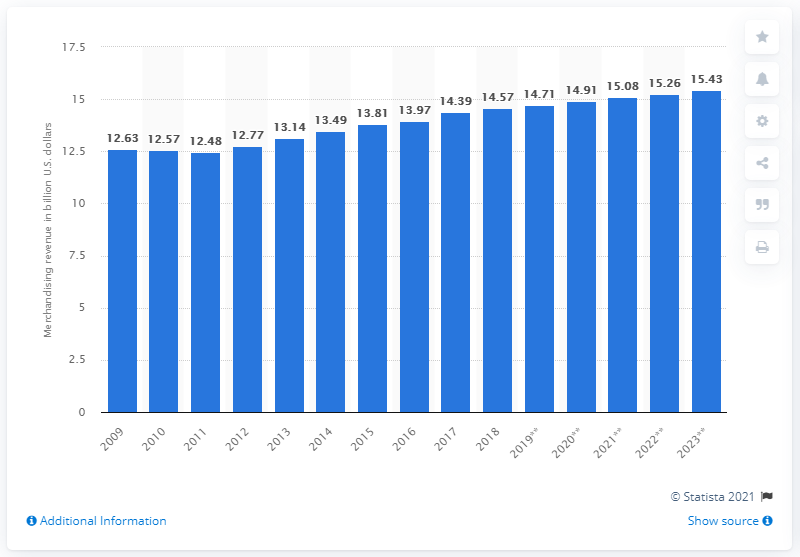Point out several critical features in this image. In 2018, the total amount of sports merchandise revenues in North America was 14.71 billion US dollars. 